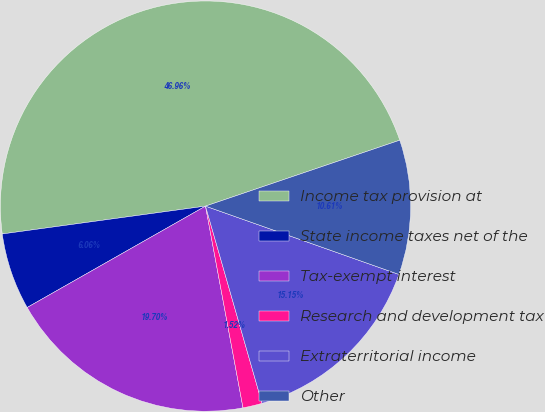<chart> <loc_0><loc_0><loc_500><loc_500><pie_chart><fcel>Income tax provision at<fcel>State income taxes net of the<fcel>Tax-exempt interest<fcel>Research and development tax<fcel>Extraterritorial income<fcel>Other<nl><fcel>46.96%<fcel>6.06%<fcel>19.7%<fcel>1.52%<fcel>15.15%<fcel>10.61%<nl></chart> 